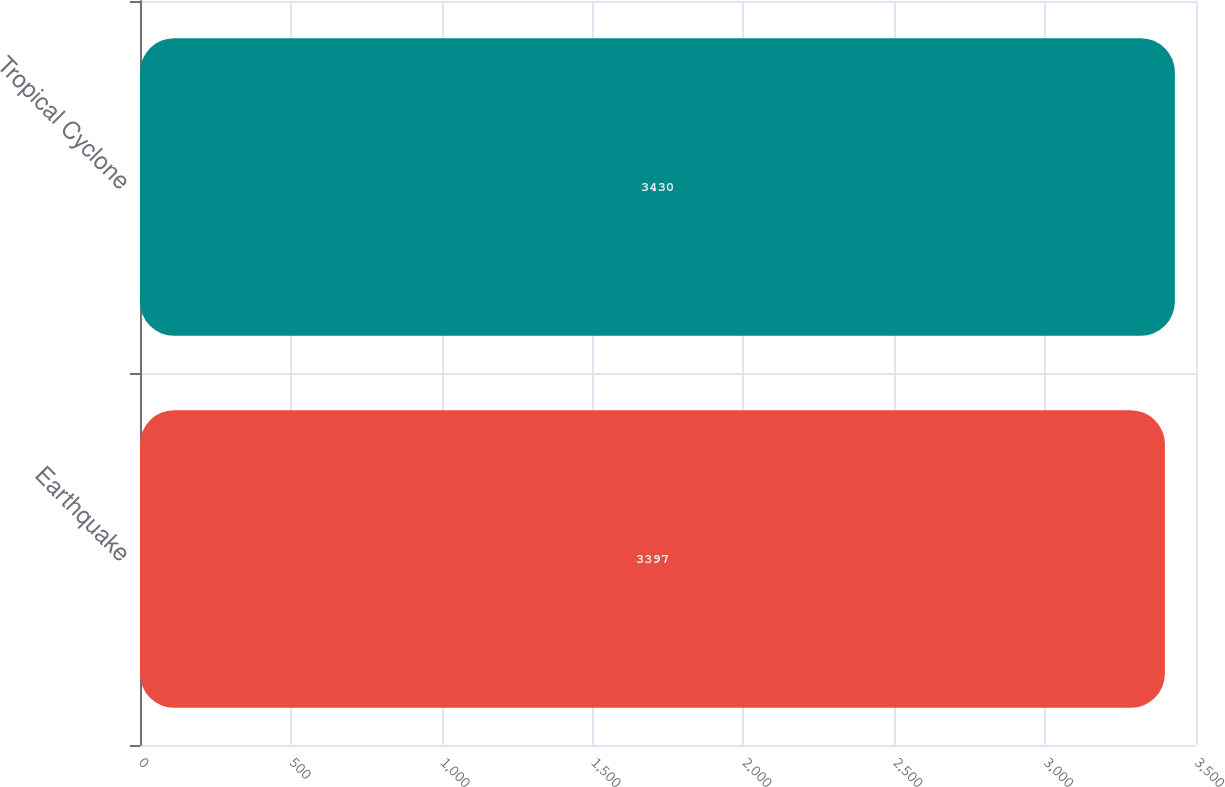<chart> <loc_0><loc_0><loc_500><loc_500><bar_chart><fcel>Earthquake<fcel>Tropical Cyclone<nl><fcel>3397<fcel>3430<nl></chart> 